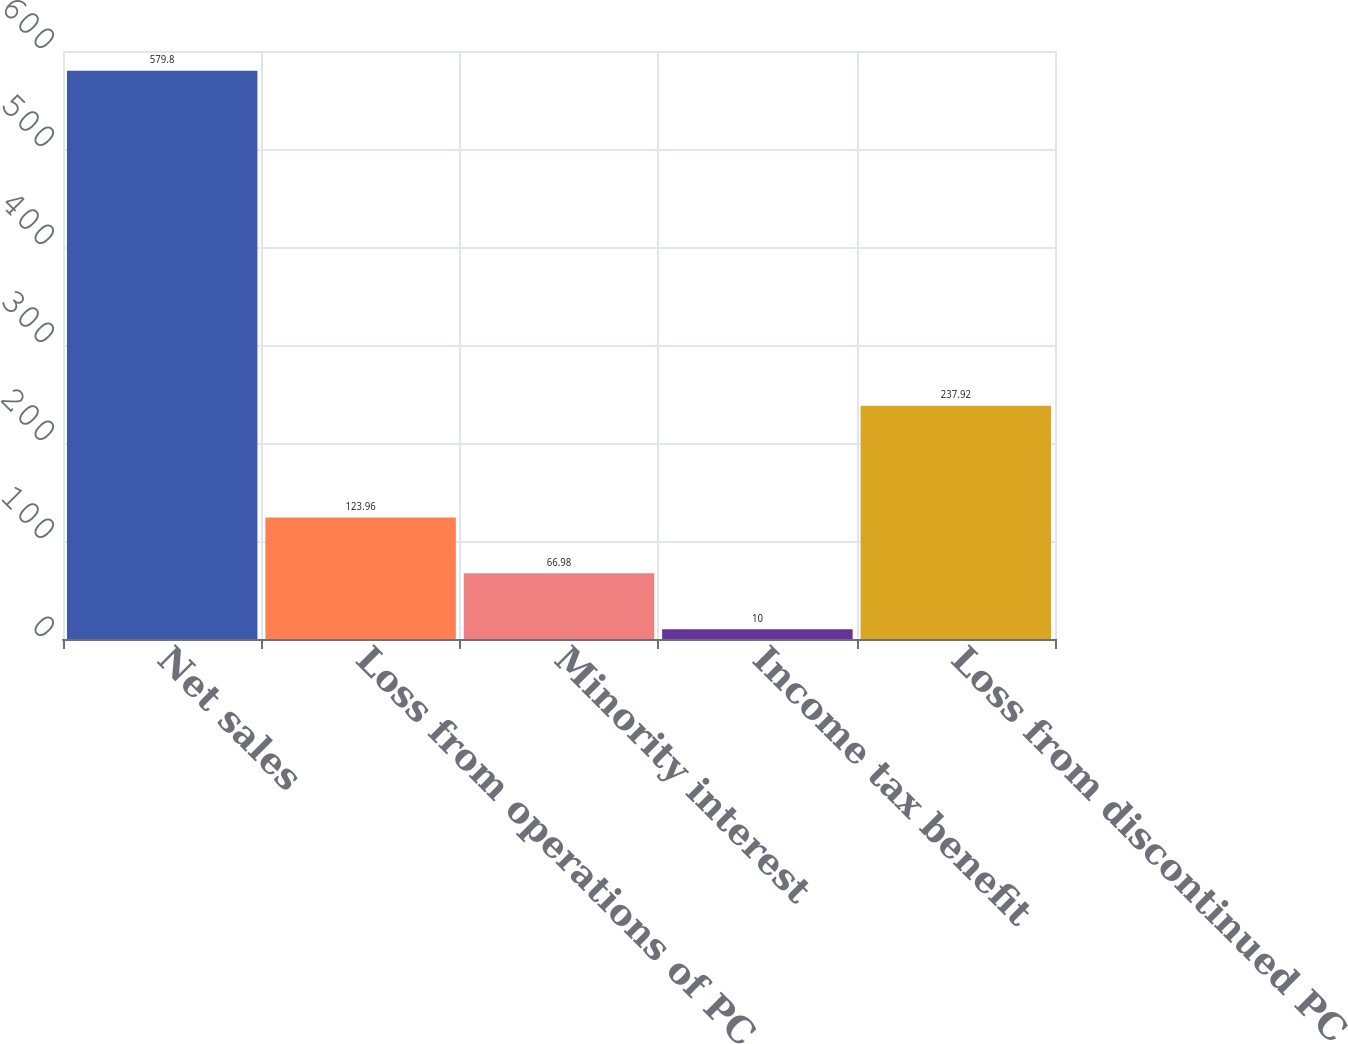Convert chart. <chart><loc_0><loc_0><loc_500><loc_500><bar_chart><fcel>Net sales<fcel>Loss from operations of PC<fcel>Minority interest<fcel>Income tax benefit<fcel>Loss from discontinued PC<nl><fcel>579.8<fcel>123.96<fcel>66.98<fcel>10<fcel>237.92<nl></chart> 